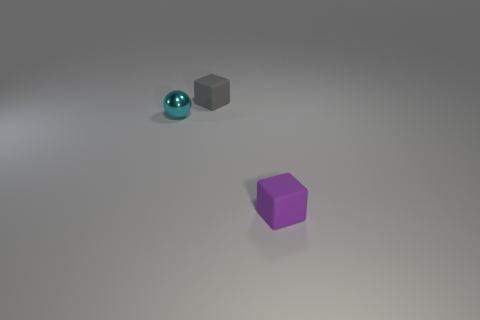There is a cyan thing; is it the same size as the matte object that is in front of the small cyan metallic object?
Your response must be concise. Yes. What is the material of the small block behind the small matte cube to the right of the gray matte object?
Your answer should be very brief. Rubber. Are there an equal number of gray matte things in front of the tiny sphere and cyan cylinders?
Keep it short and to the point. Yes. How big is the object that is both to the right of the tiny cyan sphere and behind the tiny purple rubber thing?
Your response must be concise. Small. The small rubber block that is behind the rubber block that is in front of the small metal object is what color?
Offer a very short reply. Gray. How many yellow things are either metallic balls or cubes?
Provide a short and direct response. 0. There is a object that is both in front of the small gray matte object and right of the cyan object; what color is it?
Provide a succinct answer. Purple. How many large objects are either balls or brown matte things?
Provide a succinct answer. 0. What is the size of the gray thing that is the same shape as the tiny purple matte object?
Ensure brevity in your answer.  Small. The tiny purple thing is what shape?
Ensure brevity in your answer.  Cube. 